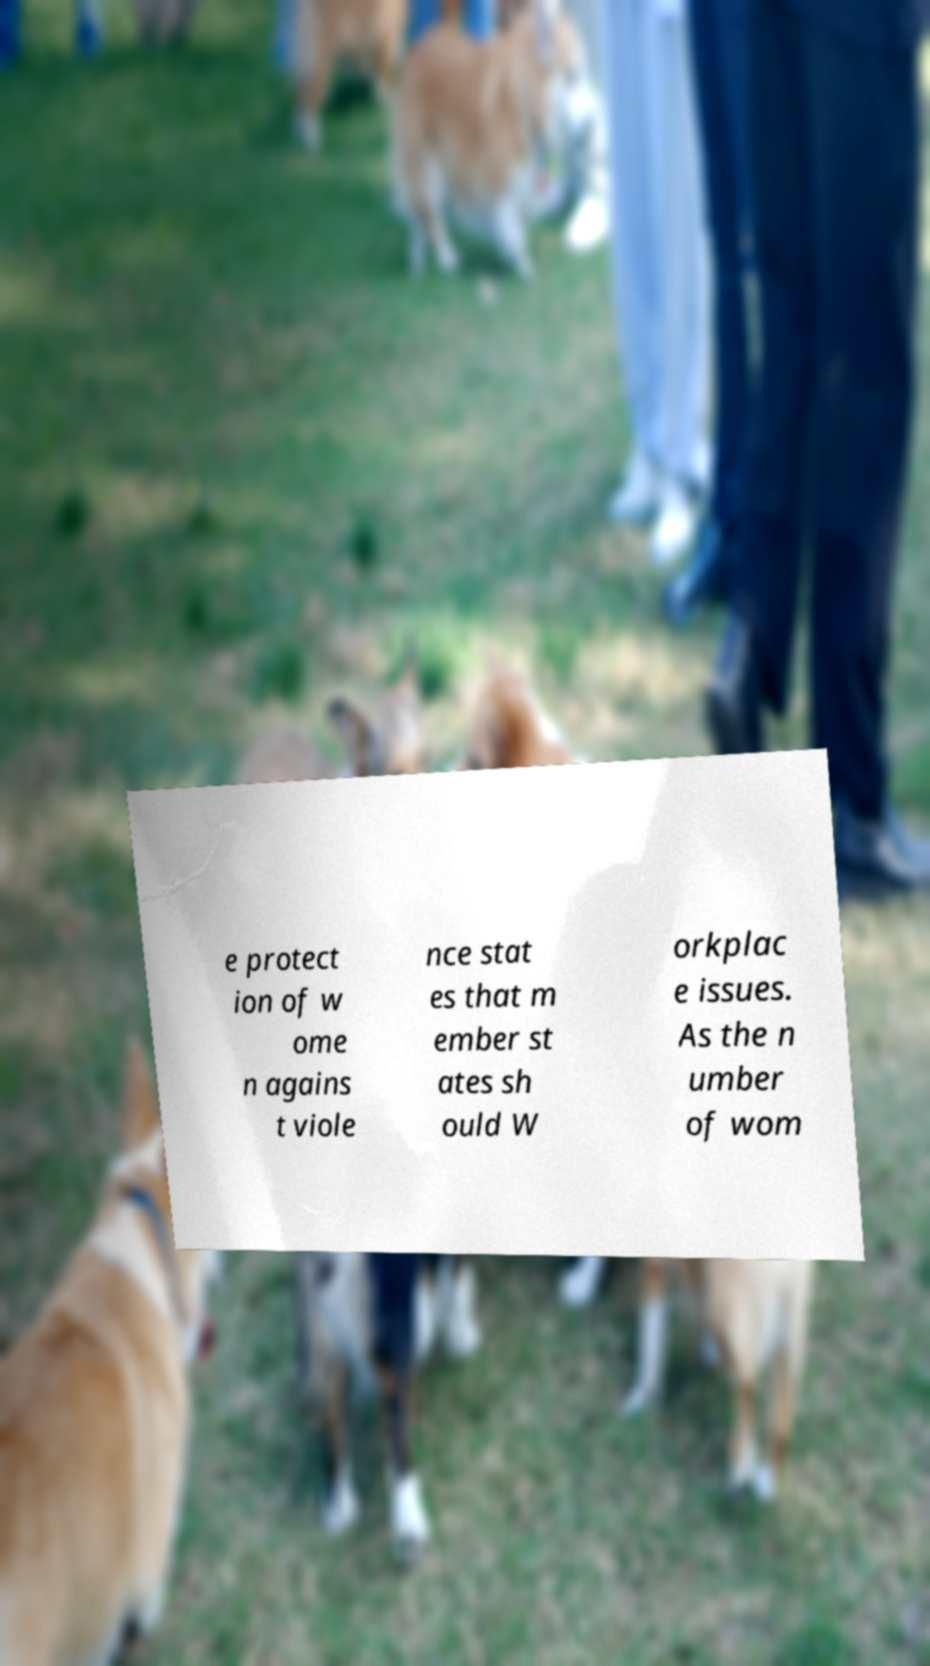Can you read and provide the text displayed in the image?This photo seems to have some interesting text. Can you extract and type it out for me? e protect ion of w ome n agains t viole nce stat es that m ember st ates sh ould W orkplac e issues. As the n umber of wom 